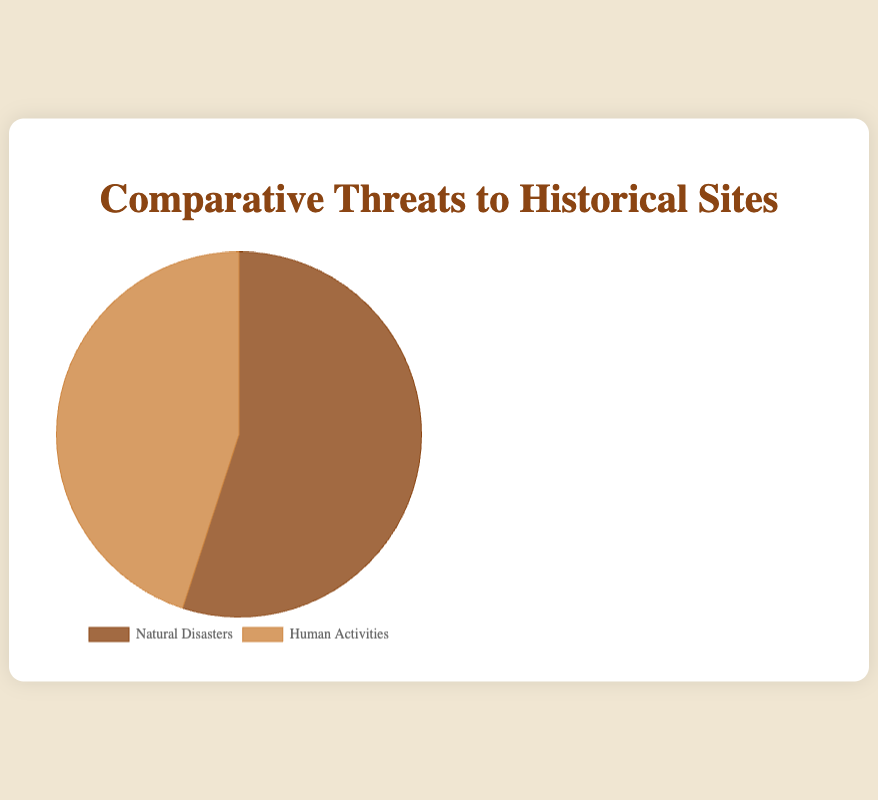What are the two main types of threats to historical sites shown in the figure? There are two main segments in the pie chart labeled 'Natural Disasters' and 'Human Activities,' which represent the two main types of threats.
Answer: Natural Disasters and Human Activities Which form of threat contributes more to the endangerment of historical sites, Natural Disasters or Human Activities? By comparing the sizes of the two pie segments, we see that 'Natural Disasters' occupies a larger portion of the pie chart than 'Human Activities.'
Answer: Natural Disasters What percentage of threats to historical sites is due to Human Activities? According to the labels on the chart, the segment labeled 'Human Activities' accounts for 45% of the pie chart.
Answer: 45% How much larger is the percentage of Natural Disasters compared to Human Activities? To find the difference between the percentages, subtract the percentage of 'Human Activities' from 'Natural Disasters': 55% - 45% = 10%.
Answer: 10% What can be inferred about the color coding in the chart? The pie chart uses different colors to represent 'Natural Disasters' and 'Human Activities.' 'Natural Disasters' is shown in a darker brown color, while 'Human Activities' is shown in a lighter brown color. This helps distinguish the two categories.
Answer: Different colors for each threat Is the threat of Natural Disasters exactly half of the total threats? The percentage given for Natural Disasters is 55%, which is slightly more than half.
Answer: No Can you name an example of natural disasters affecting historical sites and the specific sites they impact? One example of natural disasters affecting historical sites is 'Earthquake.' The historical sites impacted by earthquakes include Machu Picchu and Pompeii.
Answer: Earthquake affects Machu Picchu and Pompeii How much more do Natural Disasters contribute to threats compared to Urban Development among human activities? Natural Disasters account for 55% of threats. Urban Development, under Human Activities, contributes 20%. Comparing the two, Natural Disasters contribute 55% - 20% = 35% more.
Answer: 35% more What is the cumulative percentage of the impact of 'Flooding' and 'Hurricanes' under Natural Disasters? To find the cumulative percentage, add the percentages of 'Flooding' and 'Hurricanes': 20% + 10% = 30%.
Answer: 30% What are the combined contributions of Pollution and Vandalism among human activities to the threats? Adding the percentages for 'Pollution' and 'Vandalism' from the 'Human Activities' data: 15% + 10% = 25%.
Answer: 25% 